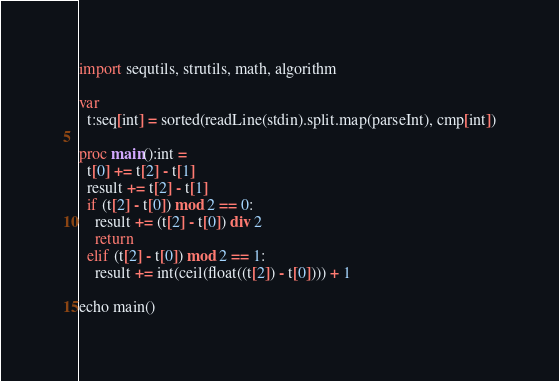<code> <loc_0><loc_0><loc_500><loc_500><_Nim_>import sequtils, strutils, math, algorithm

var
  t:seq[int] = sorted(readLine(stdin).split.map(parseInt), cmp[int])

proc main():int =
  t[0] += t[2] - t[1]
  result += t[2] - t[1]
  if (t[2] - t[0]) mod 2 == 0:
    result += (t[2] - t[0]) div 2
    return
  elif (t[2] - t[0]) mod 2 == 1:
    result += int(ceil(float((t[2]) - t[0]))) + 1

echo main()</code> 